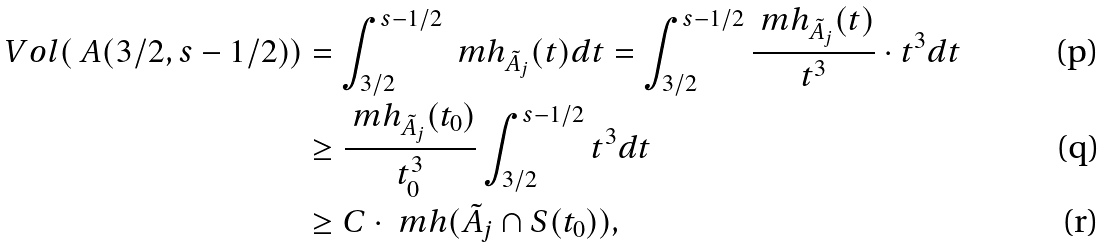<formula> <loc_0><loc_0><loc_500><loc_500>V o l ( \ A ( 3 / 2 , s - 1 / 2 ) ) & = \int _ { 3 / 2 } ^ { s - 1 / 2 } \ m h _ { \tilde { A } _ { j } } ( t ) d t = \int _ { 3 / 2 } ^ { s - 1 / 2 } \frac { \ m h _ { \tilde { A } _ { j } } ( t ) } { t ^ { 3 } } \cdot t ^ { 3 } d t \\ & \geq \frac { \ m h _ { \tilde { A } _ { j } } ( t _ { 0 } ) } { t _ { 0 } ^ { 3 } } \int _ { 3 / 2 } ^ { s - 1 / 2 } t ^ { 3 } d t \\ & \geq C \cdot \ m h ( \tilde { A } _ { j } \cap S ( t _ { 0 } ) ) ,</formula> 